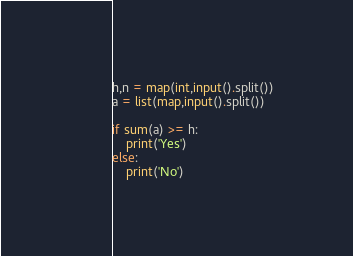Convert code to text. <code><loc_0><loc_0><loc_500><loc_500><_Python_>h,n = map(int,input().split())
a = list(map,input().split())

if sum(a) >= h:
    print('Yes')
else:
    print('No')
</code> 